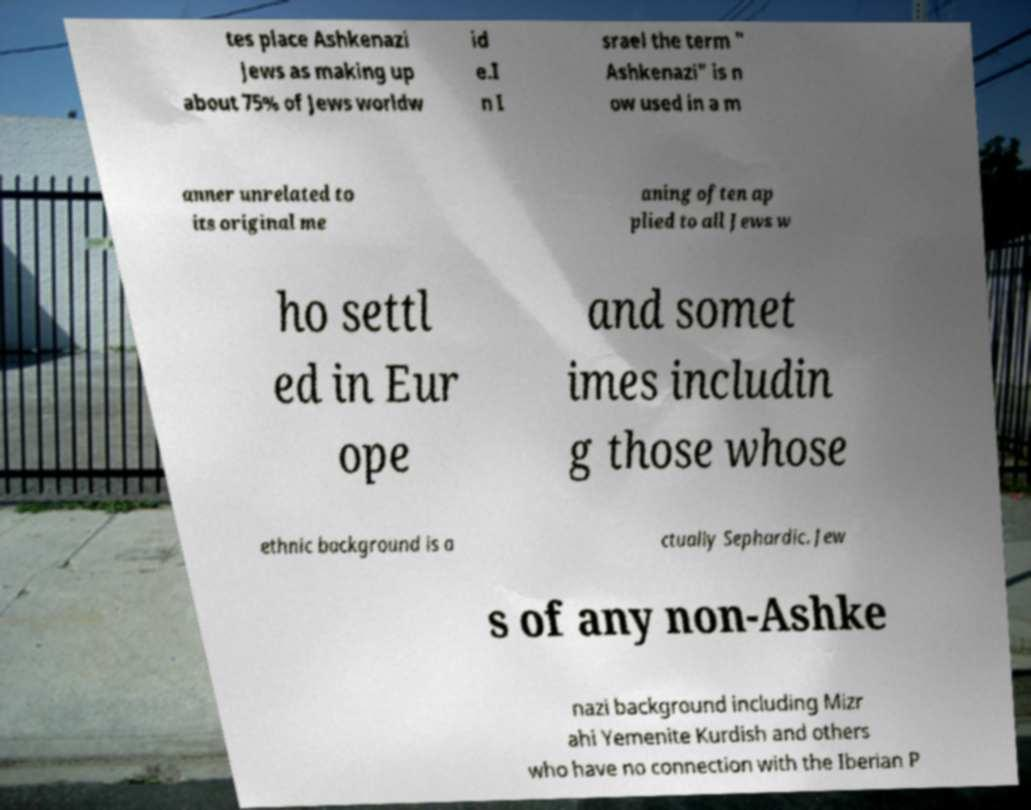Could you assist in decoding the text presented in this image and type it out clearly? tes place Ashkenazi Jews as making up about 75% of Jews worldw id e.I n I srael the term " Ashkenazi" is n ow used in a m anner unrelated to its original me aning often ap plied to all Jews w ho settl ed in Eur ope and somet imes includin g those whose ethnic background is a ctually Sephardic. Jew s of any non-Ashke nazi background including Mizr ahi Yemenite Kurdish and others who have no connection with the Iberian P 